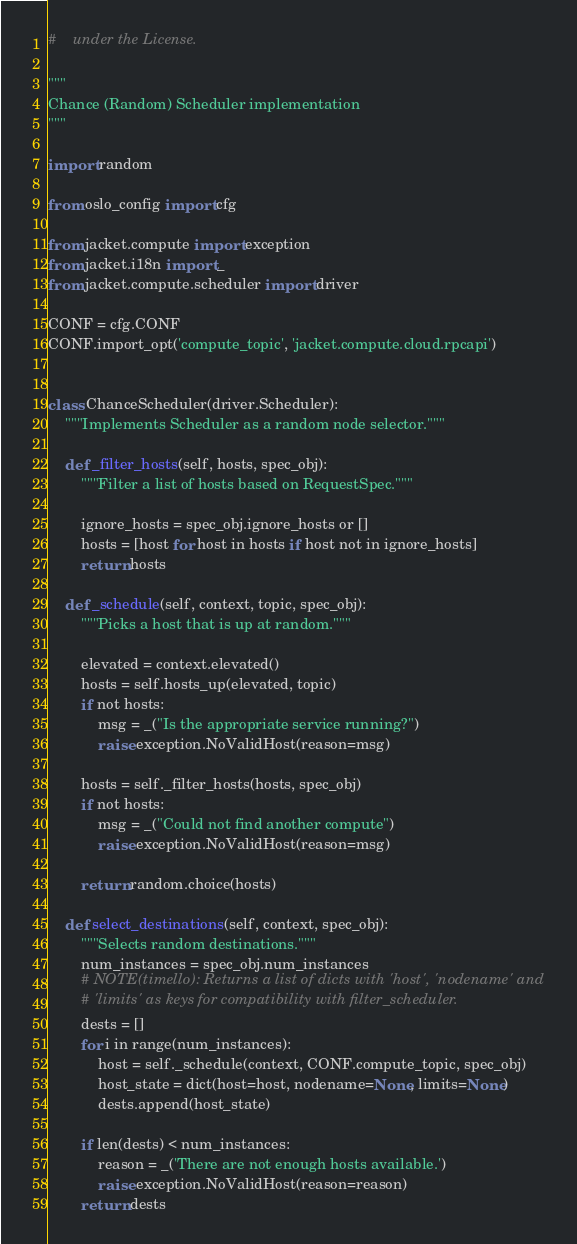<code> <loc_0><loc_0><loc_500><loc_500><_Python_>#    under the License.

"""
Chance (Random) Scheduler implementation
"""

import random

from oslo_config import cfg

from jacket.compute import exception
from jacket.i18n import _
from jacket.compute.scheduler import driver

CONF = cfg.CONF
CONF.import_opt('compute_topic', 'jacket.compute.cloud.rpcapi')


class ChanceScheduler(driver.Scheduler):
    """Implements Scheduler as a random node selector."""

    def _filter_hosts(self, hosts, spec_obj):
        """Filter a list of hosts based on RequestSpec."""

        ignore_hosts = spec_obj.ignore_hosts or []
        hosts = [host for host in hosts if host not in ignore_hosts]
        return hosts

    def _schedule(self, context, topic, spec_obj):
        """Picks a host that is up at random."""

        elevated = context.elevated()
        hosts = self.hosts_up(elevated, topic)
        if not hosts:
            msg = _("Is the appropriate service running?")
            raise exception.NoValidHost(reason=msg)

        hosts = self._filter_hosts(hosts, spec_obj)
        if not hosts:
            msg = _("Could not find another compute")
            raise exception.NoValidHost(reason=msg)

        return random.choice(hosts)

    def select_destinations(self, context, spec_obj):
        """Selects random destinations."""
        num_instances = spec_obj.num_instances
        # NOTE(timello): Returns a list of dicts with 'host', 'nodename' and
        # 'limits' as keys for compatibility with filter_scheduler.
        dests = []
        for i in range(num_instances):
            host = self._schedule(context, CONF.compute_topic, spec_obj)
            host_state = dict(host=host, nodename=None, limits=None)
            dests.append(host_state)

        if len(dests) < num_instances:
            reason = _('There are not enough hosts available.')
            raise exception.NoValidHost(reason=reason)
        return dests
</code> 